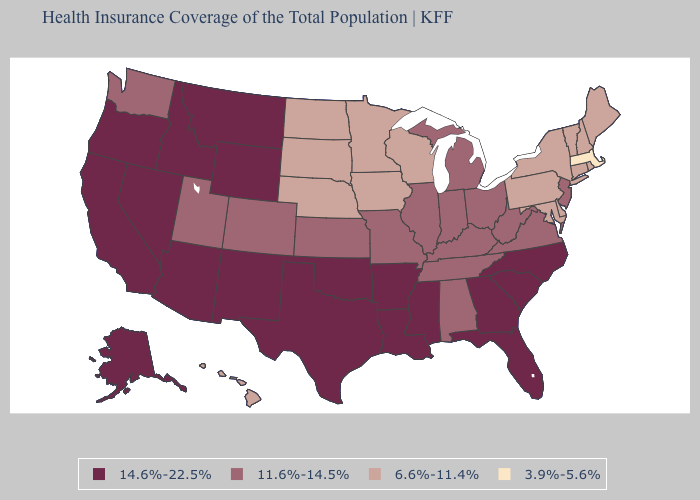Which states have the highest value in the USA?
Short answer required. Alaska, Arizona, Arkansas, California, Florida, Georgia, Idaho, Louisiana, Mississippi, Montana, Nevada, New Mexico, North Carolina, Oklahoma, Oregon, South Carolina, Texas, Wyoming. What is the lowest value in the USA?
Concise answer only. 3.9%-5.6%. Does Illinois have the highest value in the USA?
Be succinct. No. Does the map have missing data?
Concise answer only. No. Name the states that have a value in the range 3.9%-5.6%?
Concise answer only. Massachusetts. Among the states that border Oklahoma , which have the lowest value?
Quick response, please. Colorado, Kansas, Missouri. What is the lowest value in the West?
Give a very brief answer. 6.6%-11.4%. Does Arizona have the highest value in the USA?
Write a very short answer. Yes. What is the highest value in states that border Vermont?
Short answer required. 6.6%-11.4%. Among the states that border Arizona , does Nevada have the lowest value?
Write a very short answer. No. How many symbols are there in the legend?
Write a very short answer. 4. Name the states that have a value in the range 11.6%-14.5%?
Keep it brief. Alabama, Colorado, Illinois, Indiana, Kansas, Kentucky, Michigan, Missouri, New Jersey, Ohio, Tennessee, Utah, Virginia, Washington, West Virginia. Among the states that border Michigan , does Wisconsin have the highest value?
Short answer required. No. What is the lowest value in the USA?
Give a very brief answer. 3.9%-5.6%. 